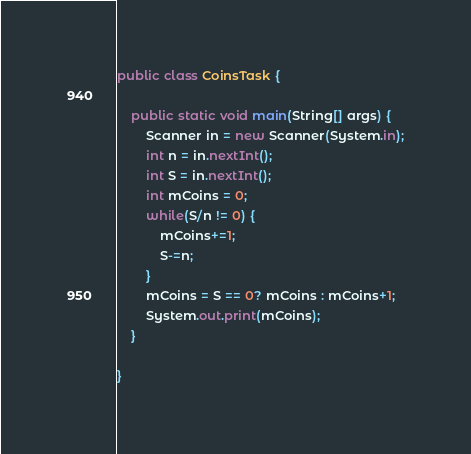Convert code to text. <code><loc_0><loc_0><loc_500><loc_500><_Java_>public class CoinsTask {
	
	public static void main(String[] args) {
		Scanner in = new Scanner(System.in);
		int n = in.nextInt();
		int S = in.nextInt();
		int mCoins = 0;
		while(S/n != 0) {
			mCoins+=1;
			S-=n;
		}
		mCoins = S == 0? mCoins : mCoins+1;
		System.out.print(mCoins);
	}

}
</code> 